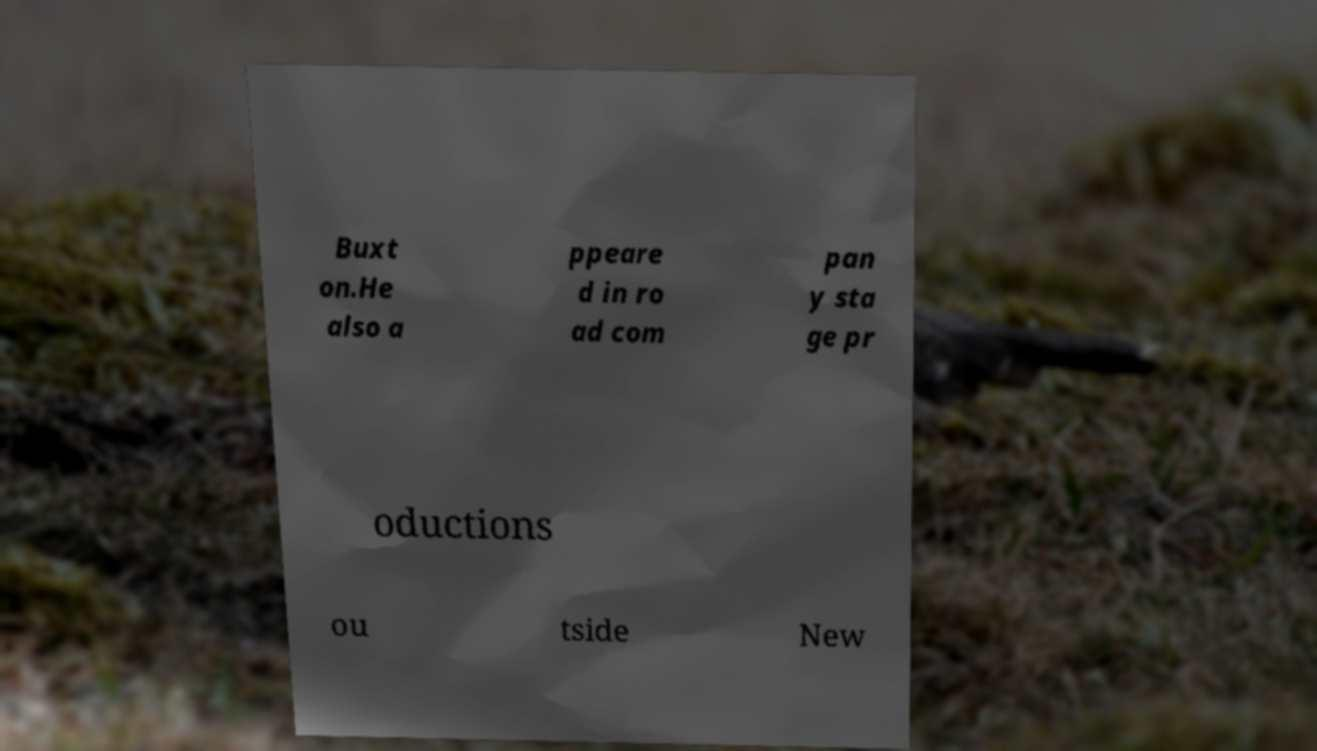Please identify and transcribe the text found in this image. Buxt on.He also a ppeare d in ro ad com pan y sta ge pr oductions ou tside New 